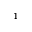<formula> <loc_0><loc_0><loc_500><loc_500>^ { 1 }</formula> 